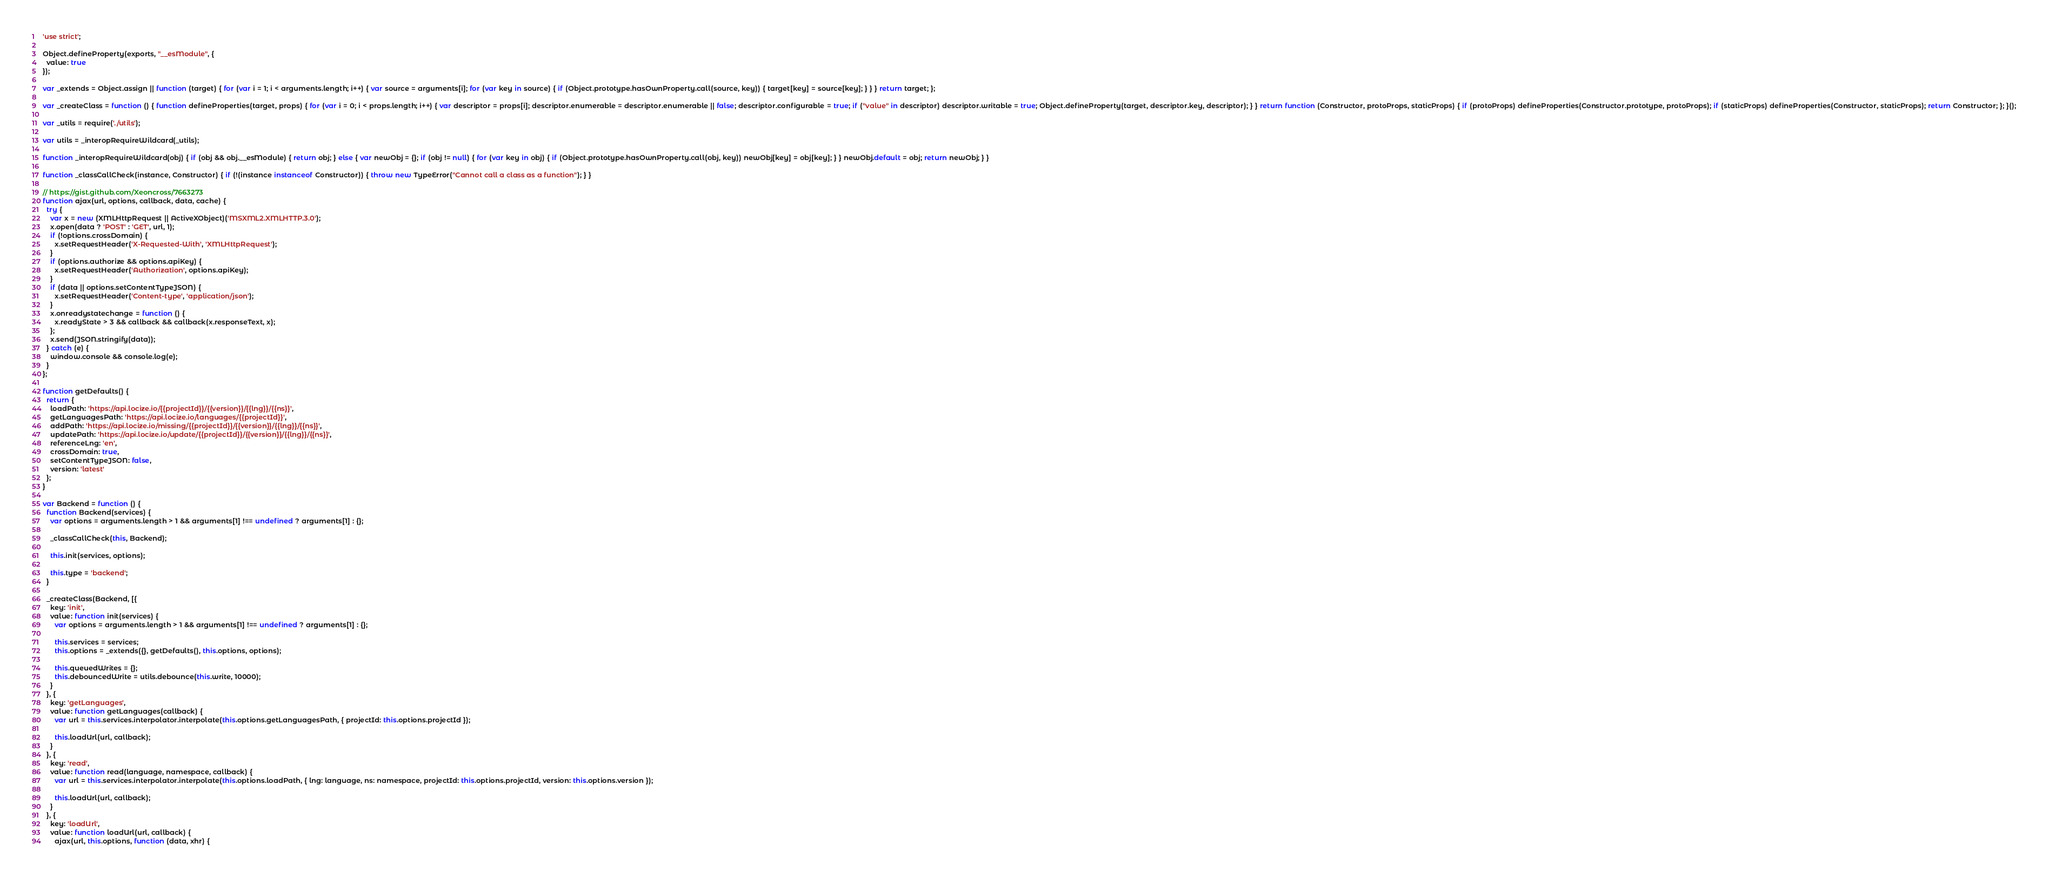Convert code to text. <code><loc_0><loc_0><loc_500><loc_500><_JavaScript_>'use strict';

Object.defineProperty(exports, "__esModule", {
  value: true
});

var _extends = Object.assign || function (target) { for (var i = 1; i < arguments.length; i++) { var source = arguments[i]; for (var key in source) { if (Object.prototype.hasOwnProperty.call(source, key)) { target[key] = source[key]; } } } return target; };

var _createClass = function () { function defineProperties(target, props) { for (var i = 0; i < props.length; i++) { var descriptor = props[i]; descriptor.enumerable = descriptor.enumerable || false; descriptor.configurable = true; if ("value" in descriptor) descriptor.writable = true; Object.defineProperty(target, descriptor.key, descriptor); } } return function (Constructor, protoProps, staticProps) { if (protoProps) defineProperties(Constructor.prototype, protoProps); if (staticProps) defineProperties(Constructor, staticProps); return Constructor; }; }();

var _utils = require('./utils');

var utils = _interopRequireWildcard(_utils);

function _interopRequireWildcard(obj) { if (obj && obj.__esModule) { return obj; } else { var newObj = {}; if (obj != null) { for (var key in obj) { if (Object.prototype.hasOwnProperty.call(obj, key)) newObj[key] = obj[key]; } } newObj.default = obj; return newObj; } }

function _classCallCheck(instance, Constructor) { if (!(instance instanceof Constructor)) { throw new TypeError("Cannot call a class as a function"); } }

// https://gist.github.com/Xeoncross/7663273
function ajax(url, options, callback, data, cache) {
  try {
    var x = new (XMLHttpRequest || ActiveXObject)('MSXML2.XMLHTTP.3.0');
    x.open(data ? 'POST' : 'GET', url, 1);
    if (!options.crossDomain) {
      x.setRequestHeader('X-Requested-With', 'XMLHttpRequest');
    }
    if (options.authorize && options.apiKey) {
      x.setRequestHeader('Authorization', options.apiKey);
    }
    if (data || options.setContentTypeJSON) {
      x.setRequestHeader('Content-type', 'application/json');
    }
    x.onreadystatechange = function () {
      x.readyState > 3 && callback && callback(x.responseText, x);
    };
    x.send(JSON.stringify(data));
  } catch (e) {
    window.console && console.log(e);
  }
};

function getDefaults() {
  return {
    loadPath: 'https://api.locize.io/{{projectId}}/{{version}}/{{lng}}/{{ns}}',
    getLanguagesPath: 'https://api.locize.io/languages/{{projectId}}',
    addPath: 'https://api.locize.io/missing/{{projectId}}/{{version}}/{{lng}}/{{ns}}',
    updatePath: 'https://api.locize.io/update/{{projectId}}/{{version}}/{{lng}}/{{ns}}',
    referenceLng: 'en',
    crossDomain: true,
    setContentTypeJSON: false,
    version: 'latest'
  };
}

var Backend = function () {
  function Backend(services) {
    var options = arguments.length > 1 && arguments[1] !== undefined ? arguments[1] : {};

    _classCallCheck(this, Backend);

    this.init(services, options);

    this.type = 'backend';
  }

  _createClass(Backend, [{
    key: 'init',
    value: function init(services) {
      var options = arguments.length > 1 && arguments[1] !== undefined ? arguments[1] : {};

      this.services = services;
      this.options = _extends({}, getDefaults(), this.options, options);

      this.queuedWrites = {};
      this.debouncedWrite = utils.debounce(this.write, 10000);
    }
  }, {
    key: 'getLanguages',
    value: function getLanguages(callback) {
      var url = this.services.interpolator.interpolate(this.options.getLanguagesPath, { projectId: this.options.projectId });

      this.loadUrl(url, callback);
    }
  }, {
    key: 'read',
    value: function read(language, namespace, callback) {
      var url = this.services.interpolator.interpolate(this.options.loadPath, { lng: language, ns: namespace, projectId: this.options.projectId, version: this.options.version });

      this.loadUrl(url, callback);
    }
  }, {
    key: 'loadUrl',
    value: function loadUrl(url, callback) {
      ajax(url, this.options, function (data, xhr) {</code> 